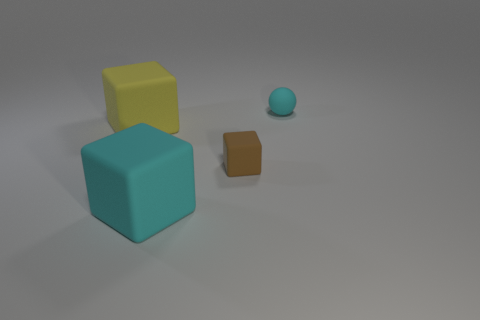There is a tiny rubber block; are there any cyan matte objects behind it?
Make the answer very short. Yes. Are there more cyan rubber objects that are behind the big yellow rubber cube than small brown things that are on the right side of the tiny cyan sphere?
Offer a terse response. Yes. What size is the cyan object that is the same shape as the tiny brown matte object?
Offer a very short reply. Large. What number of blocks are either brown objects or small red shiny objects?
Offer a terse response. 1. What material is the big object that is the same color as the tiny ball?
Your response must be concise. Rubber. Is the number of large matte objects behind the big yellow matte cube less than the number of large objects that are behind the big cyan block?
Offer a very short reply. Yes. How many objects are cyan rubber objects that are behind the large yellow block or large rubber cylinders?
Your answer should be very brief. 1. There is a cyan object that is behind the big cube that is behind the brown object; what shape is it?
Offer a very short reply. Sphere. Is there a cyan sphere that has the same size as the brown cube?
Provide a succinct answer. Yes. Is the number of green rubber balls greater than the number of big cyan objects?
Keep it short and to the point. No. 